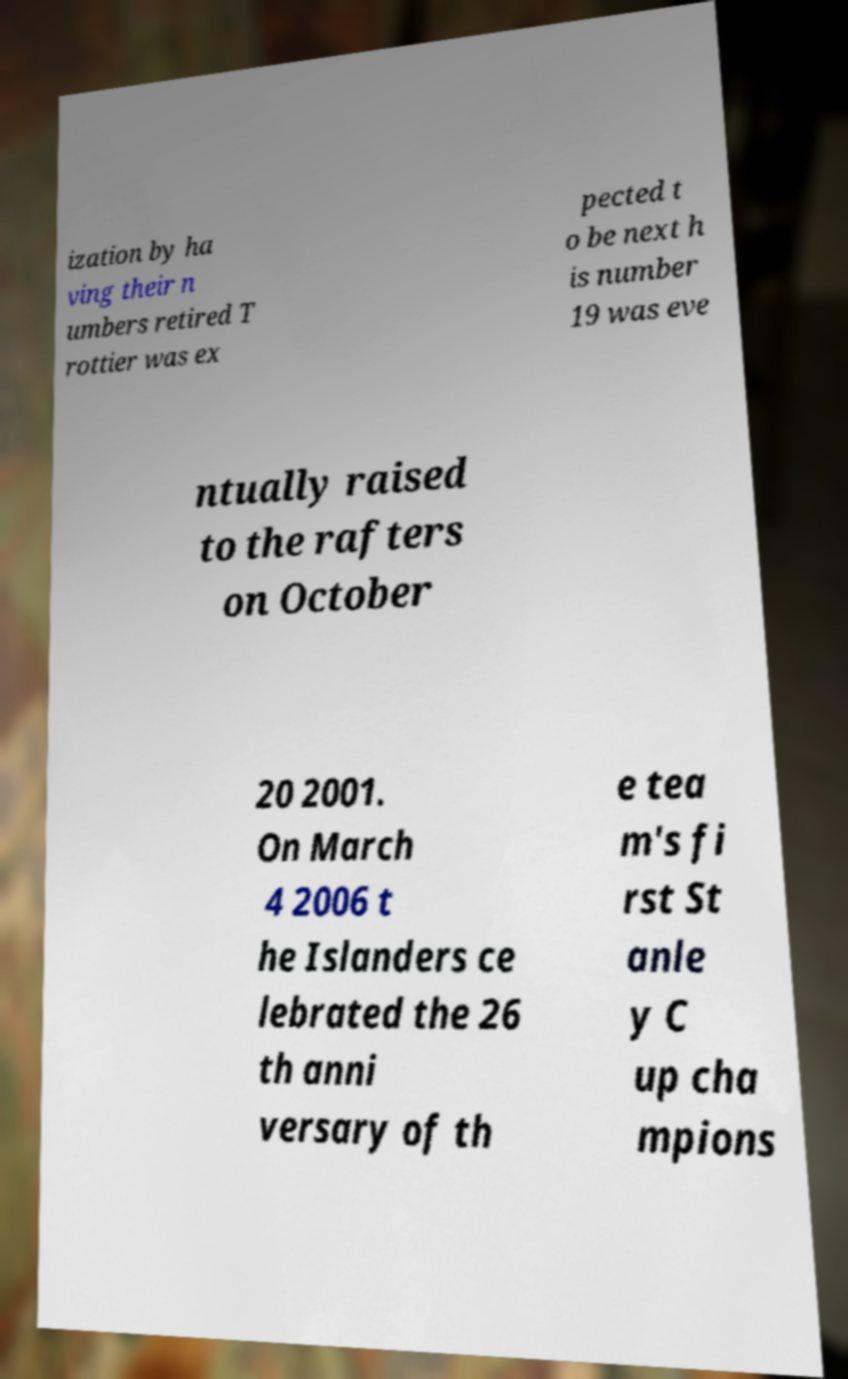For documentation purposes, I need the text within this image transcribed. Could you provide that? ization by ha ving their n umbers retired T rottier was ex pected t o be next h is number 19 was eve ntually raised to the rafters on October 20 2001. On March 4 2006 t he Islanders ce lebrated the 26 th anni versary of th e tea m's fi rst St anle y C up cha mpions 